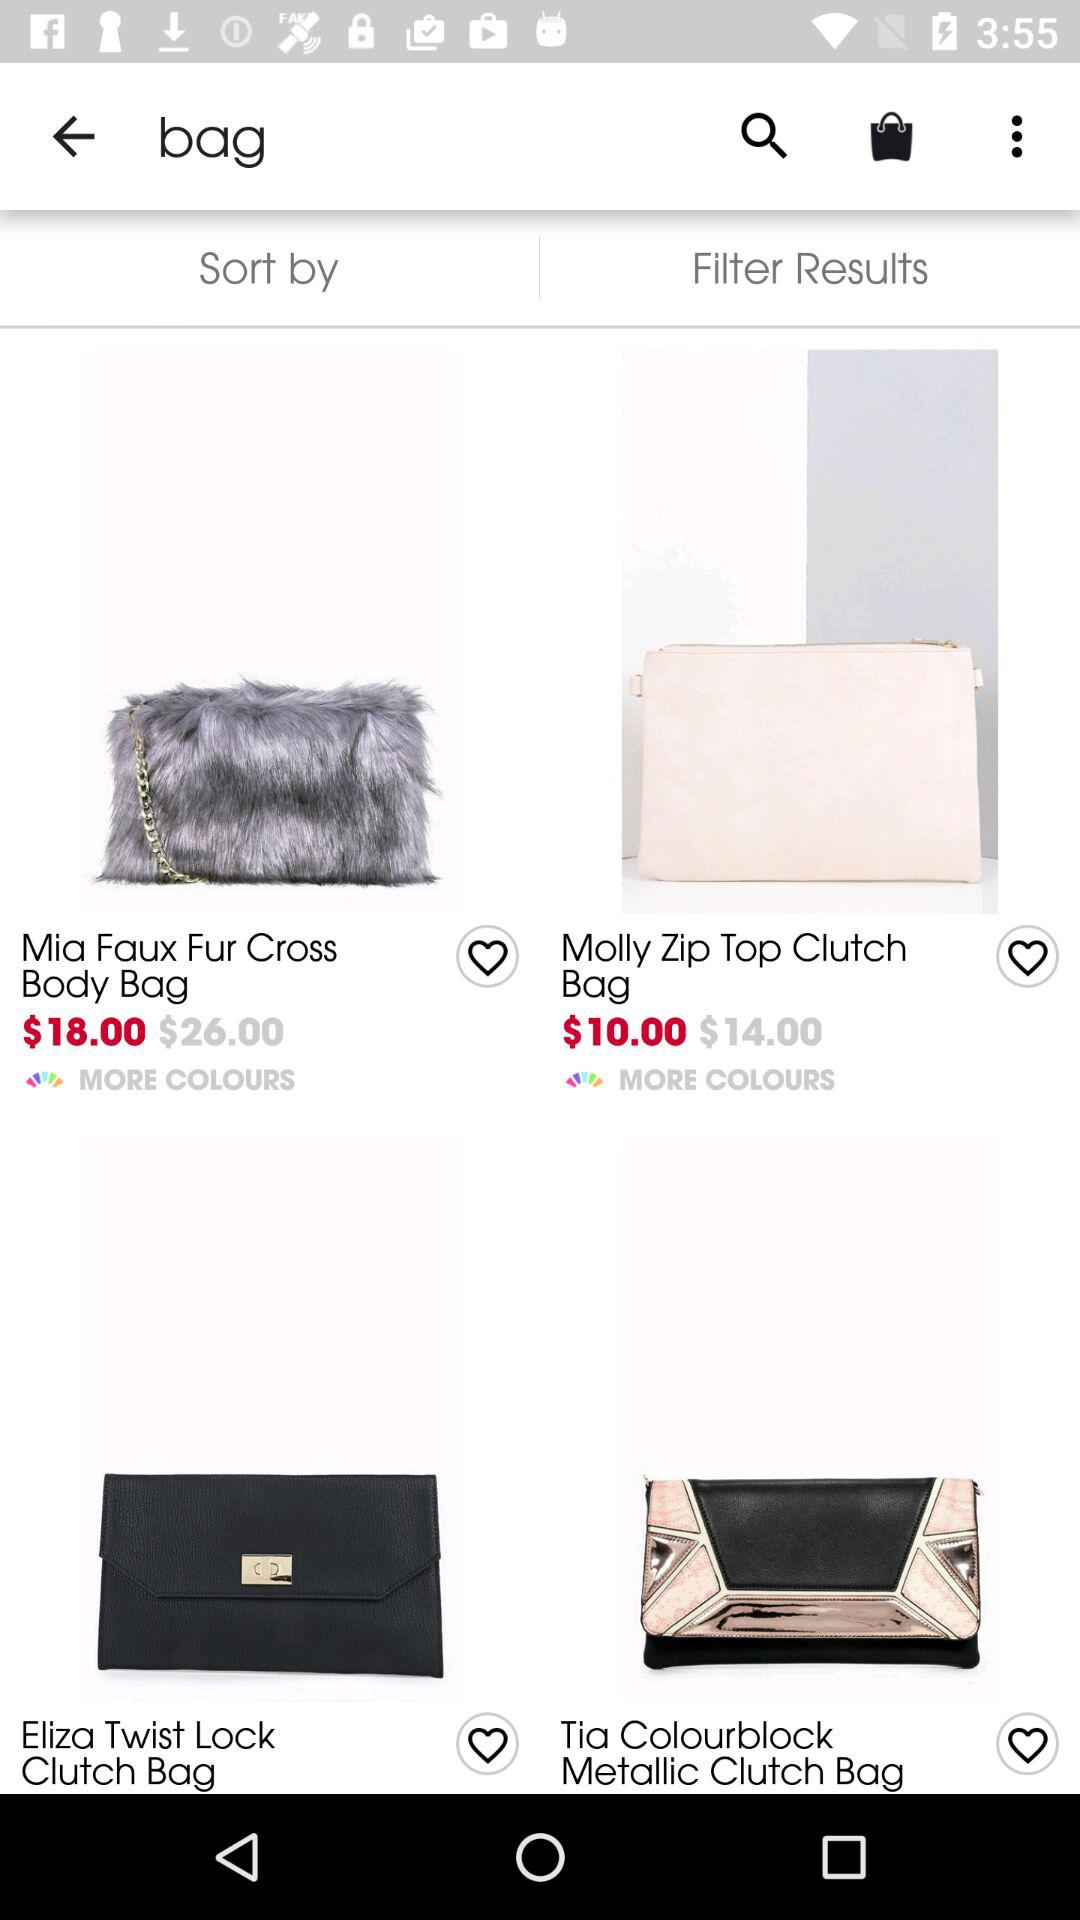What is the price of the Molly zip top clutch bag before the discount? The price is $14.00. 